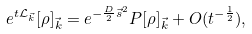<formula> <loc_0><loc_0><loc_500><loc_500>e ^ { t \mathcal { L } _ { \vec { k } } } [ \rho ] _ { \vec { k } } = e ^ { - \frac { D } { 2 } \vec { s } ^ { 2 } } P [ \rho ] _ { \vec { k } } + O ( t ^ { - \frac { 1 } { 2 } } ) ,</formula> 